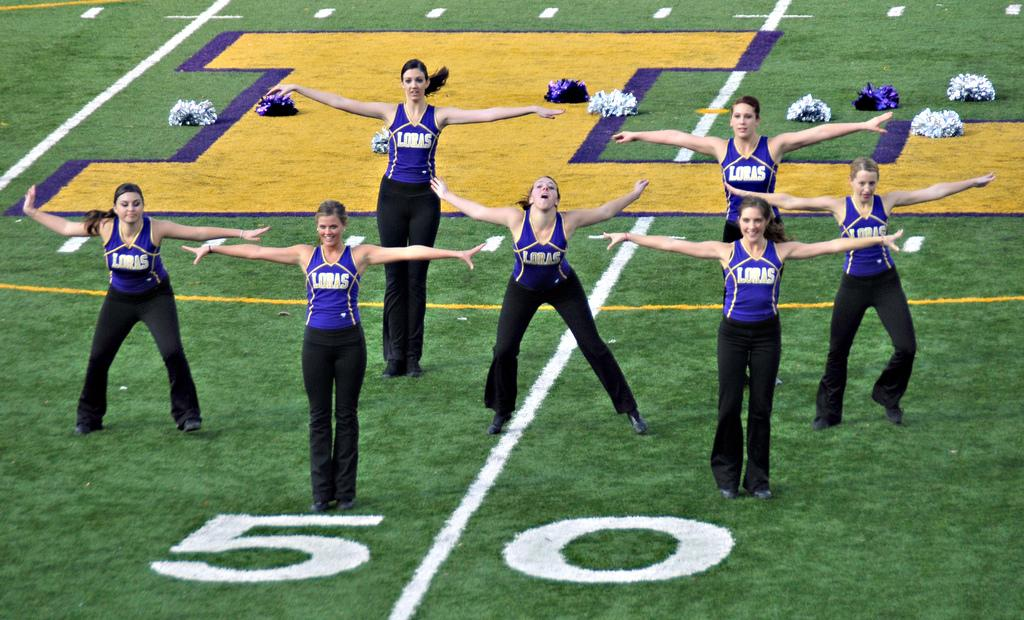Who is present in the image? There are women in the image. What are the women wearing? The women are wearing blue T-shirts and black pants. Where are the women standing? The women are standing on the ground. What additional details can be seen in the image? There is a number, some text, and a pom pom cheer visible in the image. What time is displayed on the clock in the image? There is no clock present in the image. What type of board is being used for the pom pom cheer in the image? There is no board visible in the image; only the women, their clothing, and the pom pom cheer are present. 